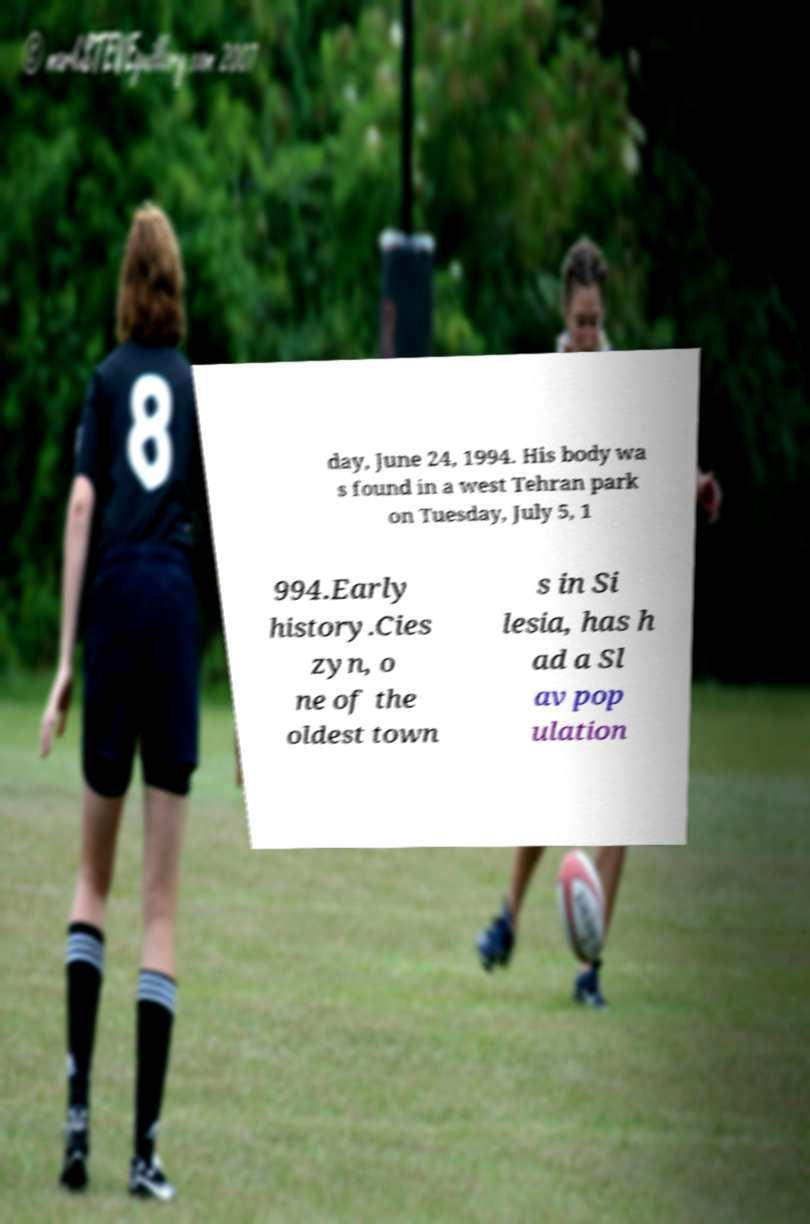Can you accurately transcribe the text from the provided image for me? day, June 24, 1994. His body wa s found in a west Tehran park on Tuesday, July 5, 1 994.Early history.Cies zyn, o ne of the oldest town s in Si lesia, has h ad a Sl av pop ulation 